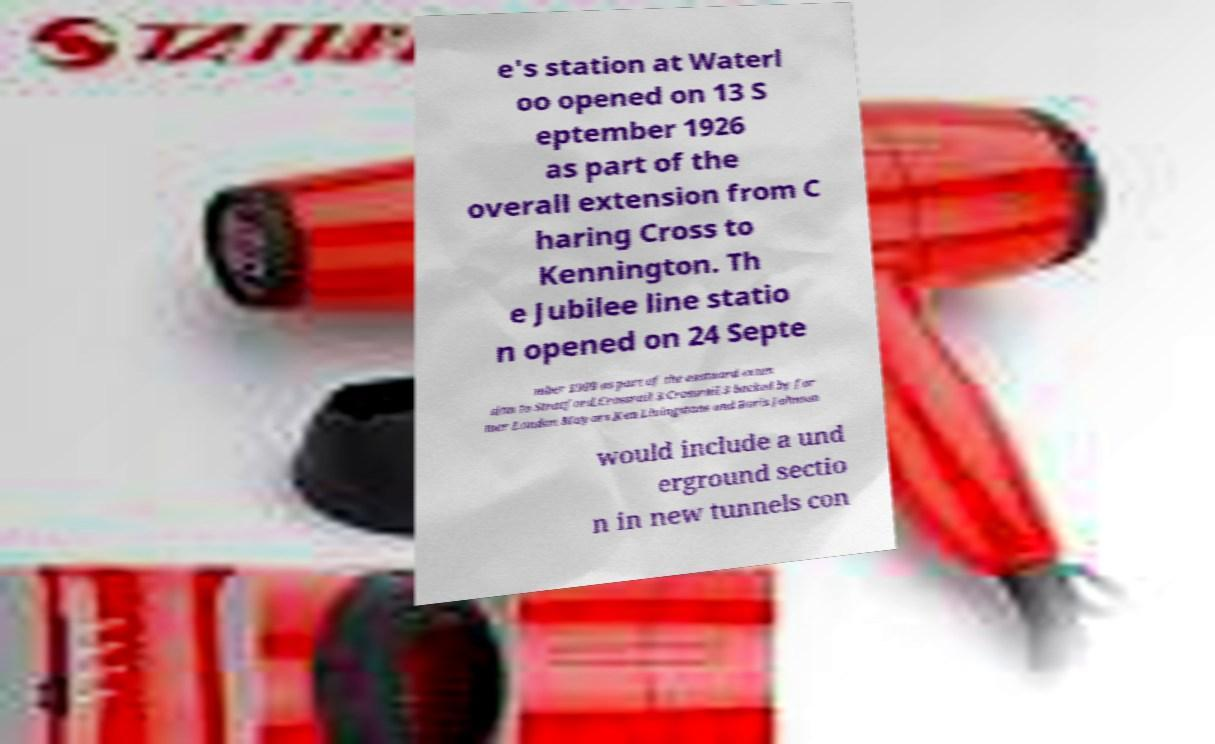Could you assist in decoding the text presented in this image and type it out clearly? e's station at Waterl oo opened on 13 S eptember 1926 as part of the overall extension from C haring Cross to Kennington. Th e Jubilee line statio n opened on 24 Septe mber 1999 as part of the eastward exten sion to Stratford.Crossrail 3.Crossrail 3 backed by for mer London Mayors Ken Livingstone and Boris Johnson would include a und erground sectio n in new tunnels con 